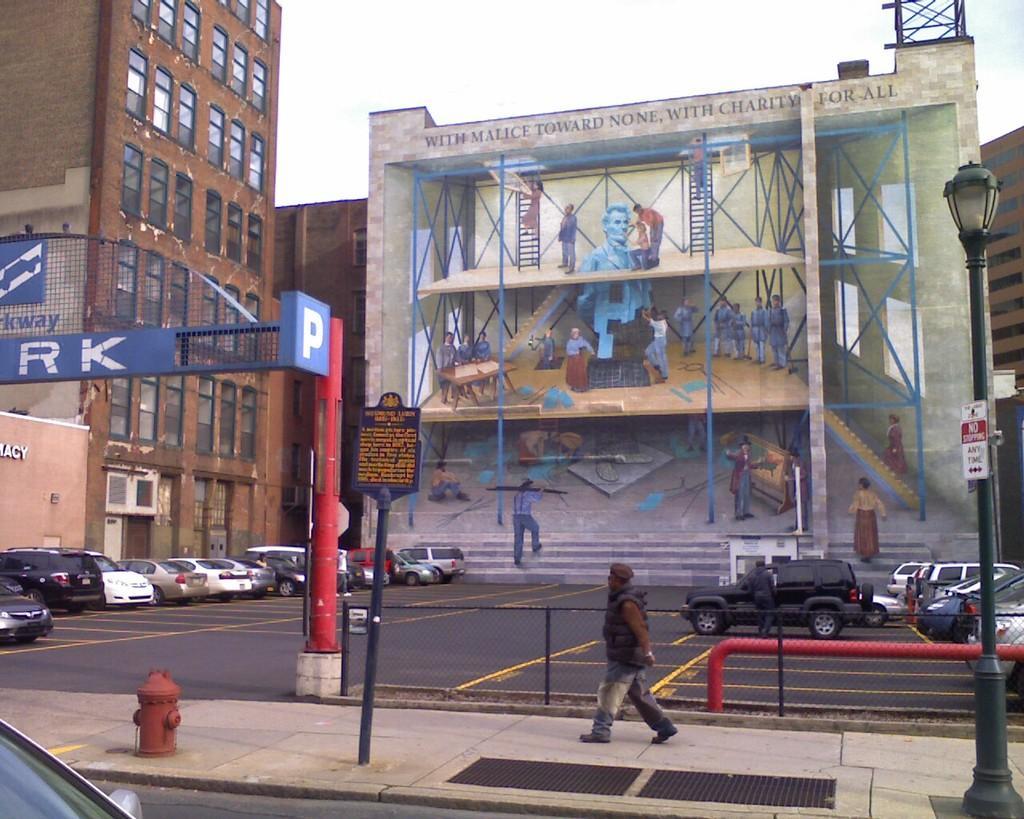In one or two sentences, can you explain what this image depicts? In this image I can see a person walking and the person is wearing brown shirt, blue pant. Background I can see few vehicles on the road, I can also see a pole in red color, buildings in brown and cream color, a light pole and the sky is in white color. 